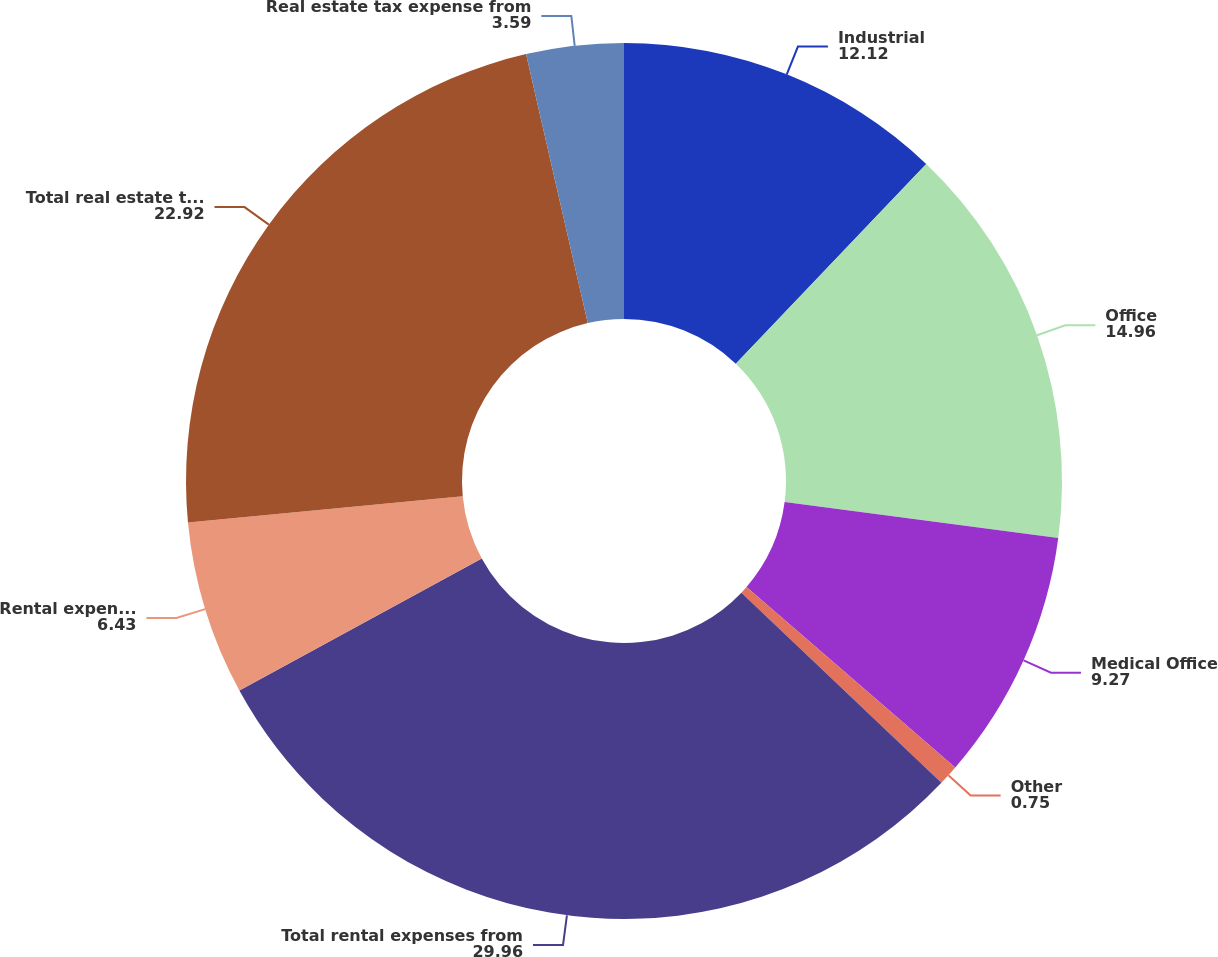Convert chart. <chart><loc_0><loc_0><loc_500><loc_500><pie_chart><fcel>Industrial<fcel>Office<fcel>Medical Office<fcel>Other<fcel>Total rental expenses from<fcel>Rental expenses from<fcel>Total real estate tax expense<fcel>Real estate tax expense from<nl><fcel>12.12%<fcel>14.96%<fcel>9.27%<fcel>0.75%<fcel>29.96%<fcel>6.43%<fcel>22.92%<fcel>3.59%<nl></chart> 